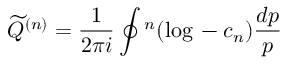Convert formula to latex. <formula><loc_0><loc_0><loc_500><loc_500>{ \widetilde { Q } } ^ { ( n ) } = \frac { 1 } { 2 \pi i } \oint \L ^ { n } ( \log \L - c _ { n } ) \frac { d p } { p }</formula> 